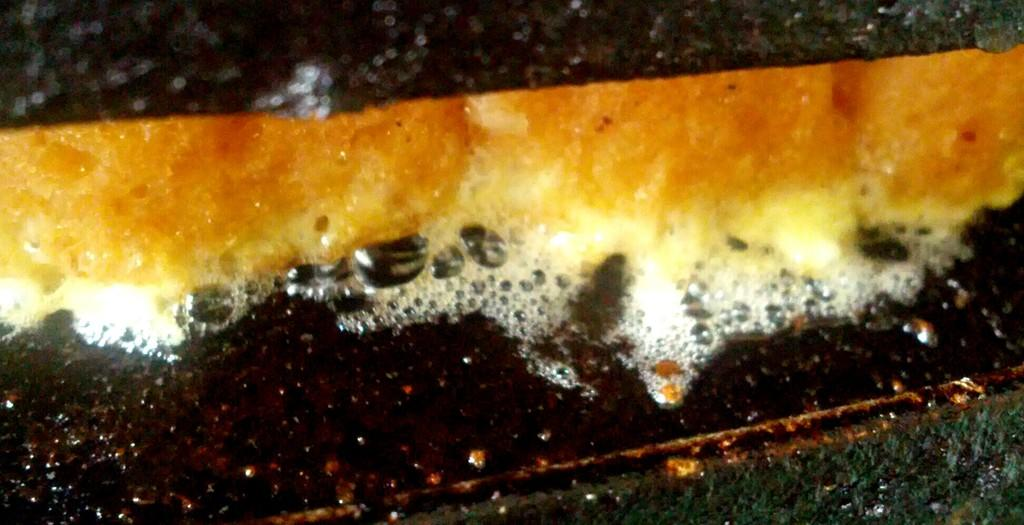What is the main subject of the image? The main subject of the image is food. Can you describe the surface on which the food is placed? The food is on a flat metal surface. How many flies are sitting on the side of the food in the image? There are no flies present in the image. 